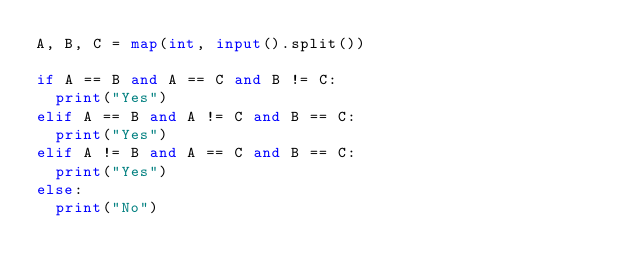<code> <loc_0><loc_0><loc_500><loc_500><_Python_>A, B, C = map(int, input().split())

if A == B and A == C and B != C:
  print("Yes")
elif A == B and A != C and B == C:
  print("Yes")
elif A != B and A == C and B == C:
  print("Yes")
else:
  print("No")</code> 